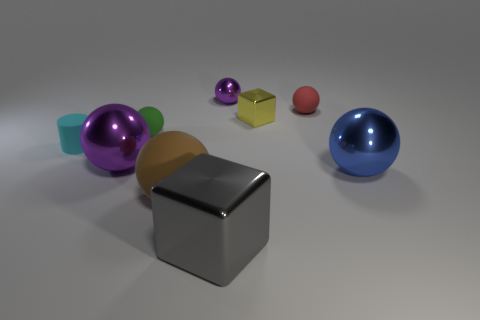Subtract all green spheres. How many spheres are left? 5 Subtract all large purple spheres. How many spheres are left? 5 Subtract 1 balls. How many balls are left? 5 Subtract all brown spheres. Subtract all brown blocks. How many spheres are left? 5 Add 1 tiny purple spheres. How many objects exist? 10 Subtract all blocks. How many objects are left? 7 Add 4 big brown spheres. How many big brown spheres exist? 5 Subtract 1 gray cubes. How many objects are left? 8 Subtract all large purple shiny balls. Subtract all yellow metal things. How many objects are left? 7 Add 4 rubber cylinders. How many rubber cylinders are left? 5 